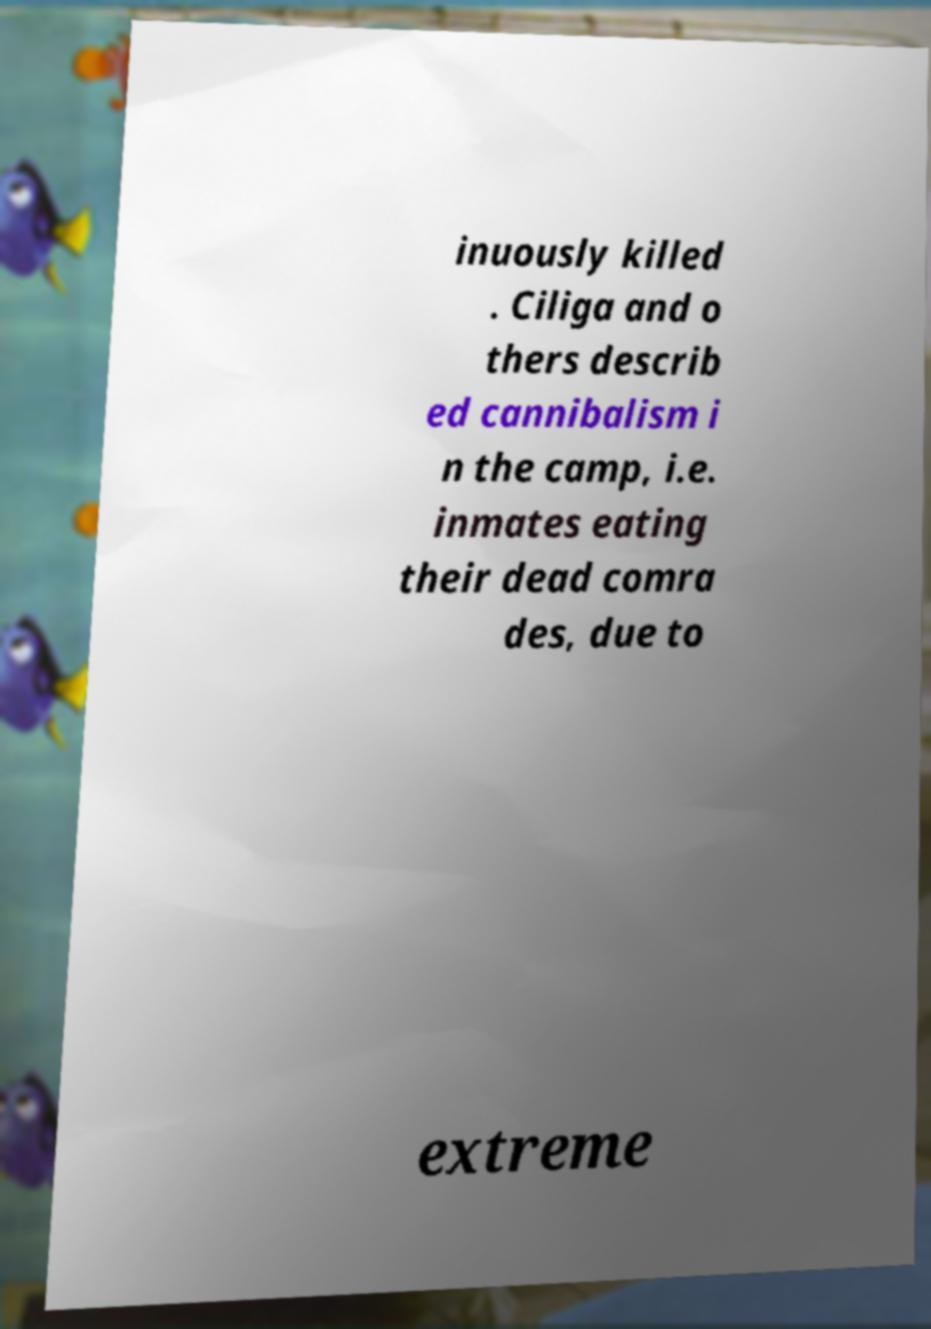What messages or text are displayed in this image? I need them in a readable, typed format. inuously killed . Ciliga and o thers describ ed cannibalism i n the camp, i.e. inmates eating their dead comra des, due to extreme 